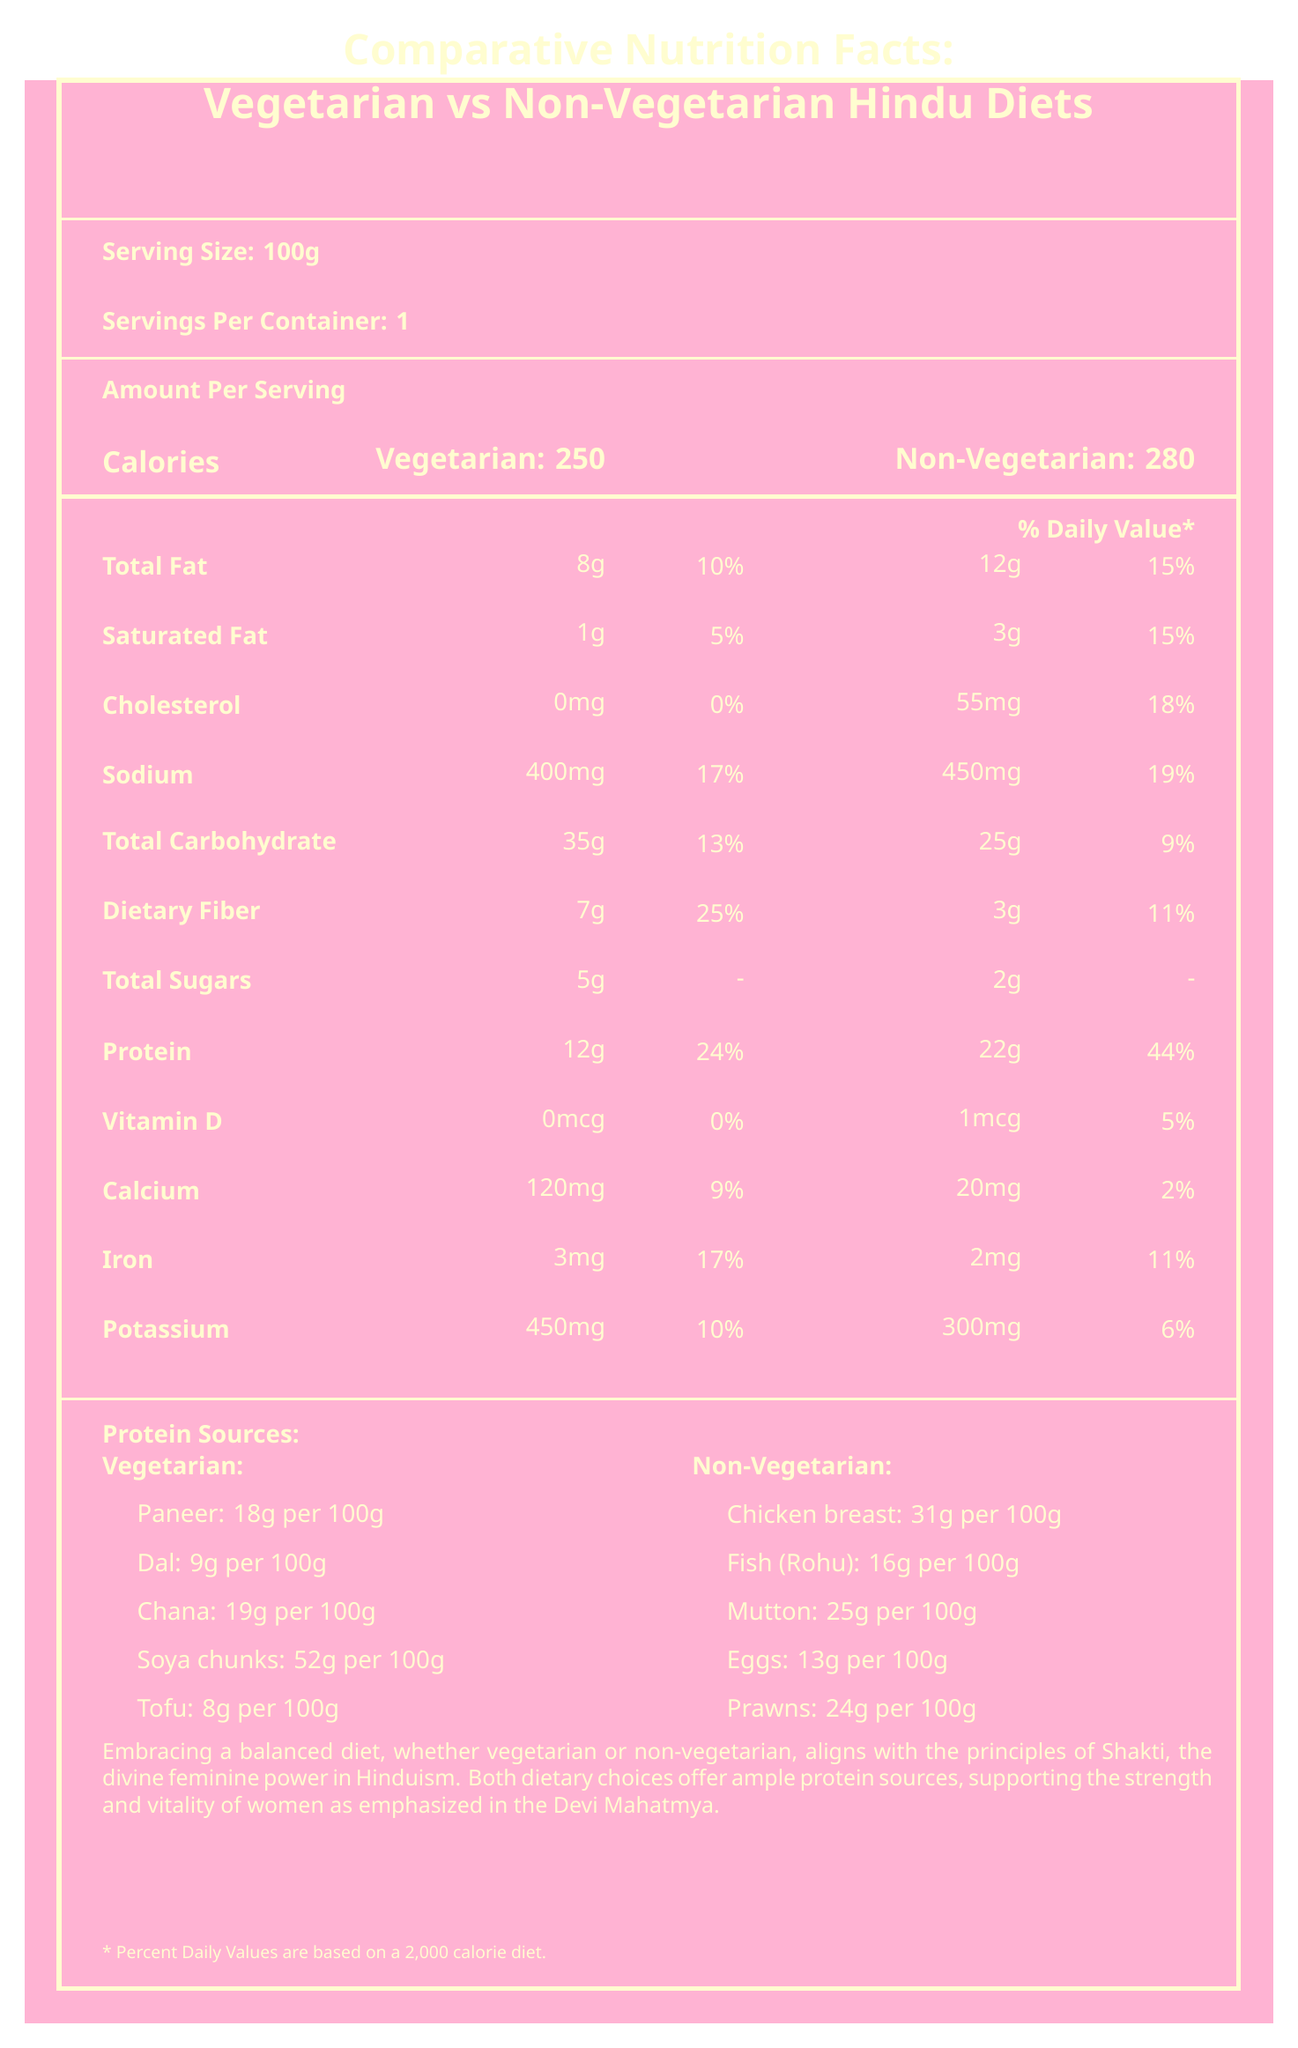who consumes more calories, vegetarians or non-vegetarians? The document shows that non-vegetarians consume 280 calories per 100g serving, whereas vegetarians consume 250 calories per 100g serving.
Answer: Non-vegetarians how much protein does tofu provide per 100g? The document lists tofu as a vegetarian protein source providing 8g of protein per 100g.
Answer: 8g which diet has a higher percentage daily value for dietary fiber? The document indicates that the vegetarian diet has a 25% daily value for dietary fiber, compared to 11% for the non-vegetarian diet.
Answer: Vegetarian what is the cholesterol content in non-vegetarian servings? The document shows that non-vegetarian servings have 55mg of cholesterol per 100g.
Answer: 55mg which nutrient has the highest daily value percentage in the non-vegetarian diet? The document shows that protein has a 44% daily value percentage in the non-vegetarian diet, which is the highest among listed nutrients for this diet.
Answer: Protein which protein source has the highest protein content per 100g? A. Dal B. Fish (Rohu) C. Soya chunks D. Chicken breast The document lists soya chunks providing 52g of protein per 100g, which is the highest compared to other sources.
Answer: C. Soya chunks which vegetarian protein source offers more protein per 100g? A. Paneer B. Dal C. Chana D. Tofu Chana provides 19g of protein per 100g, compared to Paneer (18g), Dal (9g), and Tofu (8g).
Answer: C. Chana does the vegetarian diet contain any cholesterol? The document shows that the vegetarian diet contains 0mg cholesterol per 100g serving.
Answer: No compare the total carbohydrate content between vegetarian and non-vegetarian diets. The document indicates that vegetarian diets contain 35g of total carbohydrates per 100g, whereas non-vegetarian diets contain 25g per 100g.
Answer: Vegetarians have 35g, Non-vegetarians have 25g describe the main idea of the document. The document lists various nutritional elements like calories, fats, cholesterol, sodium, carbohydrates, dietary fiber, sugars, protein, vitamins, and minerals for both vegetarian and non-vegetarian diets, with a focus on protein sources. It concludes with a message on the significance of a balanced diet in the context of Hindu beliefs.
Answer: The document provides a comparative overview of the nutrition facts for vegetarian and non-vegetarian Hindu diets, highlighting protein sources from both diets, and emphasizing the importance of a balanced diet in alignment with Hindu principles of Shakti. is the sodium content higher in vegetarian diets? The document shows that the sodium content in the non-vegetarian diet is 450mg per 100g, which is higher than the 400mg in the vegetarian diet.
Answer: No how much potassium does the vegetarian diet provide per serving? The document indicates that the vegetarian diet provides 450mg of potassium per 100g serving.
Answer: 450mg which has a higher saturated fat content per 100g, vegetarian or non-vegetarian diets? The document shows that non-vegetarian diets have 3g of saturated fat per 100g, whereas vegetarian diets have 1g per 100g.
Answer: Non-vegetarian what is the percentage daily value of calcium in the vegetarian diet? The document specifies that the vegetarian diet provides 9% of the daily value of calcium.
Answer: 9% what message does the document convey about diet choices and Hindu principles? The document emphasizes that embracing a balanced diet, whether vegetarian or non-vegetarian, aligns with Hindu principles of Shakti and supports women's strength and vitality as emphasized in the Devi Mahatmya.
Answer: Both dietary choices align with the principles of Shakti, offering ample protein sources to support women's strength and vitality. does the document specify the exact types of meals to consume for a balanced diet? The document provides nutrient data and protein sources but does not specify exact types of meals for a balanced diet.
Answer: Not enough information 